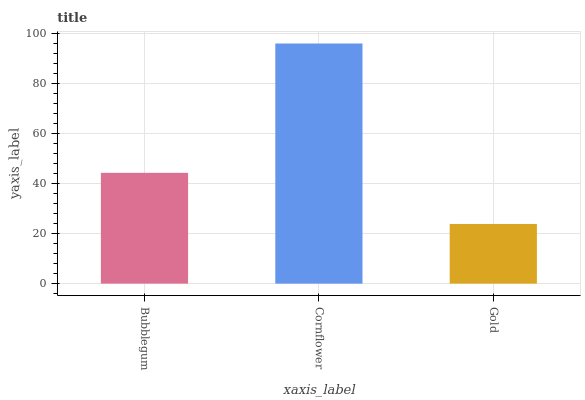Is Cornflower the minimum?
Answer yes or no. No. Is Gold the maximum?
Answer yes or no. No. Is Cornflower greater than Gold?
Answer yes or no. Yes. Is Gold less than Cornflower?
Answer yes or no. Yes. Is Gold greater than Cornflower?
Answer yes or no. No. Is Cornflower less than Gold?
Answer yes or no. No. Is Bubblegum the high median?
Answer yes or no. Yes. Is Bubblegum the low median?
Answer yes or no. Yes. Is Cornflower the high median?
Answer yes or no. No. Is Cornflower the low median?
Answer yes or no. No. 